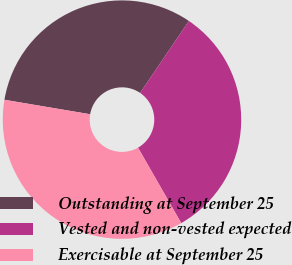Convert chart to OTSL. <chart><loc_0><loc_0><loc_500><loc_500><pie_chart><fcel>Outstanding at September 25<fcel>Vested and non-vested expected<fcel>Exercisable at September 25<nl><fcel>31.82%<fcel>32.24%<fcel>35.94%<nl></chart> 